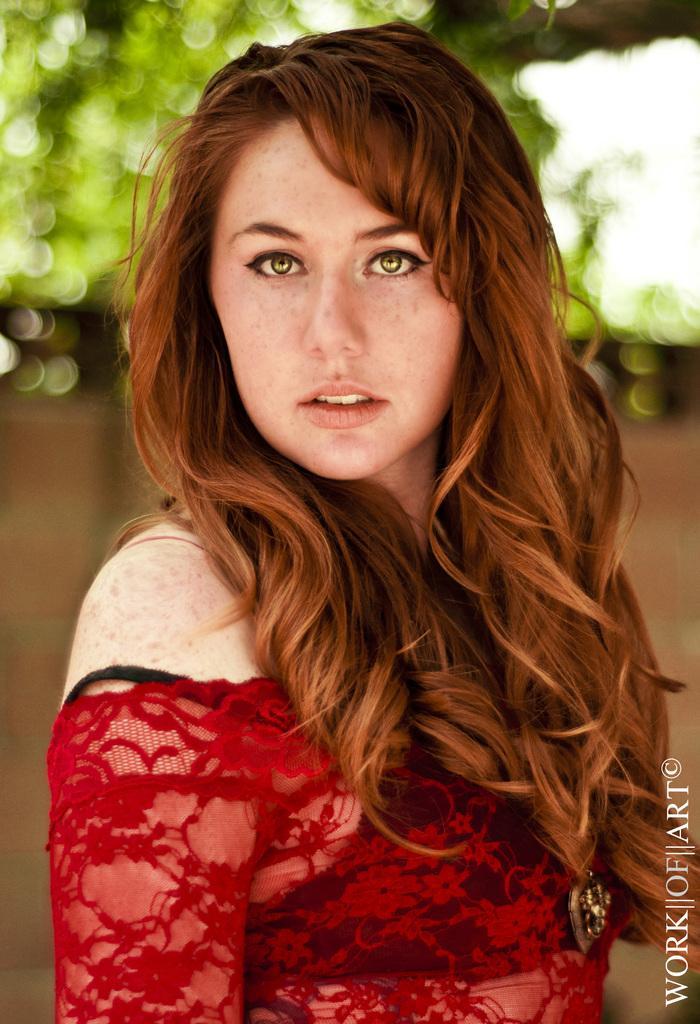How would you summarize this image in a sentence or two? In this picture we can observe a woman. She is wearing red color dress. We can observe watermark on the right side. In the background we can observe a wall and some trees. 